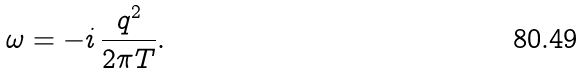<formula> <loc_0><loc_0><loc_500><loc_500>\omega = - i \, \frac { q ^ { 2 } } { 2 \pi T } .</formula> 